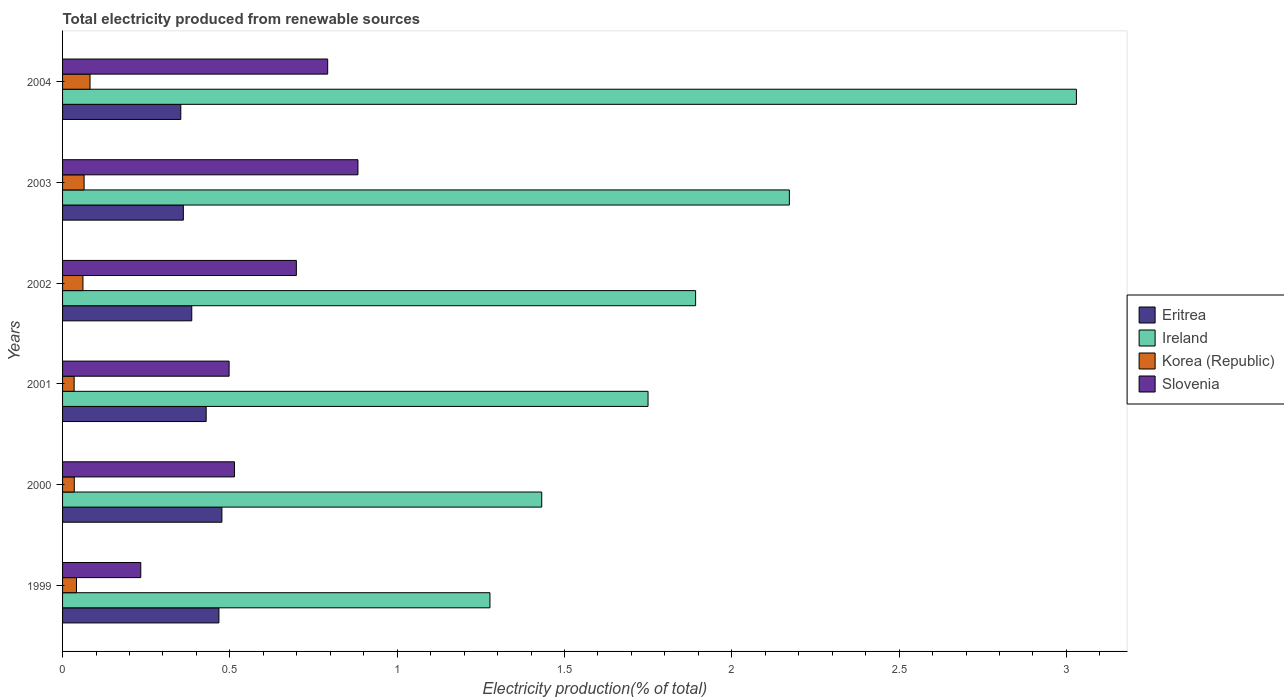How many different coloured bars are there?
Ensure brevity in your answer.  4. Are the number of bars per tick equal to the number of legend labels?
Give a very brief answer. Yes. Are the number of bars on each tick of the Y-axis equal?
Ensure brevity in your answer.  Yes. How many bars are there on the 5th tick from the top?
Your answer should be very brief. 4. How many bars are there on the 5th tick from the bottom?
Offer a very short reply. 4. What is the label of the 6th group of bars from the top?
Your answer should be very brief. 1999. What is the total electricity produced in Korea (Republic) in 2002?
Your answer should be compact. 0.06. Across all years, what is the maximum total electricity produced in Ireland?
Keep it short and to the point. 3.03. Across all years, what is the minimum total electricity produced in Ireland?
Provide a succinct answer. 1.28. In which year was the total electricity produced in Slovenia minimum?
Your answer should be compact. 1999. What is the total total electricity produced in Slovenia in the graph?
Keep it short and to the point. 3.62. What is the difference between the total electricity produced in Eritrea in 1999 and that in 2002?
Your response must be concise. 0.08. What is the difference between the total electricity produced in Korea (Republic) in 2000 and the total electricity produced in Slovenia in 2003?
Your answer should be compact. -0.85. What is the average total electricity produced in Ireland per year?
Make the answer very short. 1.93. In the year 2002, what is the difference between the total electricity produced in Ireland and total electricity produced in Eritrea?
Offer a very short reply. 1.51. What is the ratio of the total electricity produced in Korea (Republic) in 1999 to that in 2000?
Offer a terse response. 1.19. Is the total electricity produced in Ireland in 2001 less than that in 2003?
Ensure brevity in your answer.  Yes. What is the difference between the highest and the second highest total electricity produced in Korea (Republic)?
Your response must be concise. 0.02. What is the difference between the highest and the lowest total electricity produced in Slovenia?
Ensure brevity in your answer.  0.65. Is it the case that in every year, the sum of the total electricity produced in Eritrea and total electricity produced in Korea (Republic) is greater than the sum of total electricity produced in Ireland and total electricity produced in Slovenia?
Offer a very short reply. No. What does the 3rd bar from the top in 2002 represents?
Ensure brevity in your answer.  Ireland. What does the 3rd bar from the bottom in 2000 represents?
Make the answer very short. Korea (Republic). Are all the bars in the graph horizontal?
Give a very brief answer. Yes. Where does the legend appear in the graph?
Keep it short and to the point. Center right. How many legend labels are there?
Offer a terse response. 4. What is the title of the graph?
Offer a terse response. Total electricity produced from renewable sources. What is the Electricity production(% of total) in Eritrea in 1999?
Make the answer very short. 0.47. What is the Electricity production(% of total) in Ireland in 1999?
Ensure brevity in your answer.  1.28. What is the Electricity production(% of total) in Korea (Republic) in 1999?
Make the answer very short. 0.04. What is the Electricity production(% of total) in Slovenia in 1999?
Your response must be concise. 0.23. What is the Electricity production(% of total) in Eritrea in 2000?
Keep it short and to the point. 0.48. What is the Electricity production(% of total) in Ireland in 2000?
Provide a succinct answer. 1.43. What is the Electricity production(% of total) of Korea (Republic) in 2000?
Offer a terse response. 0.04. What is the Electricity production(% of total) in Slovenia in 2000?
Your answer should be compact. 0.51. What is the Electricity production(% of total) in Eritrea in 2001?
Offer a very short reply. 0.43. What is the Electricity production(% of total) of Ireland in 2001?
Provide a succinct answer. 1.75. What is the Electricity production(% of total) of Korea (Republic) in 2001?
Offer a terse response. 0.03. What is the Electricity production(% of total) of Slovenia in 2001?
Provide a succinct answer. 0.5. What is the Electricity production(% of total) of Eritrea in 2002?
Provide a succinct answer. 0.39. What is the Electricity production(% of total) in Ireland in 2002?
Your response must be concise. 1.89. What is the Electricity production(% of total) in Korea (Republic) in 2002?
Your answer should be very brief. 0.06. What is the Electricity production(% of total) in Slovenia in 2002?
Ensure brevity in your answer.  0.7. What is the Electricity production(% of total) of Eritrea in 2003?
Your answer should be very brief. 0.36. What is the Electricity production(% of total) in Ireland in 2003?
Make the answer very short. 2.17. What is the Electricity production(% of total) of Korea (Republic) in 2003?
Provide a succinct answer. 0.06. What is the Electricity production(% of total) in Slovenia in 2003?
Give a very brief answer. 0.88. What is the Electricity production(% of total) in Eritrea in 2004?
Make the answer very short. 0.35. What is the Electricity production(% of total) in Ireland in 2004?
Ensure brevity in your answer.  3.03. What is the Electricity production(% of total) of Korea (Republic) in 2004?
Your answer should be compact. 0.08. What is the Electricity production(% of total) of Slovenia in 2004?
Provide a short and direct response. 0.79. Across all years, what is the maximum Electricity production(% of total) in Eritrea?
Provide a succinct answer. 0.48. Across all years, what is the maximum Electricity production(% of total) in Ireland?
Your answer should be very brief. 3.03. Across all years, what is the maximum Electricity production(% of total) of Korea (Republic)?
Keep it short and to the point. 0.08. Across all years, what is the maximum Electricity production(% of total) in Slovenia?
Provide a short and direct response. 0.88. Across all years, what is the minimum Electricity production(% of total) of Eritrea?
Provide a succinct answer. 0.35. Across all years, what is the minimum Electricity production(% of total) in Ireland?
Ensure brevity in your answer.  1.28. Across all years, what is the minimum Electricity production(% of total) in Korea (Republic)?
Provide a short and direct response. 0.03. Across all years, what is the minimum Electricity production(% of total) in Slovenia?
Ensure brevity in your answer.  0.23. What is the total Electricity production(% of total) of Eritrea in the graph?
Your answer should be very brief. 2.47. What is the total Electricity production(% of total) of Ireland in the graph?
Your response must be concise. 11.55. What is the total Electricity production(% of total) of Korea (Republic) in the graph?
Keep it short and to the point. 0.32. What is the total Electricity production(% of total) of Slovenia in the graph?
Your answer should be compact. 3.62. What is the difference between the Electricity production(% of total) of Eritrea in 1999 and that in 2000?
Your answer should be very brief. -0.01. What is the difference between the Electricity production(% of total) of Ireland in 1999 and that in 2000?
Your answer should be compact. -0.15. What is the difference between the Electricity production(% of total) in Korea (Republic) in 1999 and that in 2000?
Offer a terse response. 0.01. What is the difference between the Electricity production(% of total) in Slovenia in 1999 and that in 2000?
Ensure brevity in your answer.  -0.28. What is the difference between the Electricity production(% of total) of Eritrea in 1999 and that in 2001?
Keep it short and to the point. 0.04. What is the difference between the Electricity production(% of total) in Ireland in 1999 and that in 2001?
Your answer should be compact. -0.47. What is the difference between the Electricity production(% of total) of Korea (Republic) in 1999 and that in 2001?
Give a very brief answer. 0.01. What is the difference between the Electricity production(% of total) of Slovenia in 1999 and that in 2001?
Your answer should be compact. -0.26. What is the difference between the Electricity production(% of total) of Eritrea in 1999 and that in 2002?
Ensure brevity in your answer.  0.08. What is the difference between the Electricity production(% of total) in Ireland in 1999 and that in 2002?
Make the answer very short. -0.61. What is the difference between the Electricity production(% of total) in Korea (Republic) in 1999 and that in 2002?
Offer a very short reply. -0.02. What is the difference between the Electricity production(% of total) of Slovenia in 1999 and that in 2002?
Ensure brevity in your answer.  -0.47. What is the difference between the Electricity production(% of total) in Eritrea in 1999 and that in 2003?
Ensure brevity in your answer.  0.11. What is the difference between the Electricity production(% of total) in Ireland in 1999 and that in 2003?
Provide a succinct answer. -0.89. What is the difference between the Electricity production(% of total) of Korea (Republic) in 1999 and that in 2003?
Make the answer very short. -0.02. What is the difference between the Electricity production(% of total) in Slovenia in 1999 and that in 2003?
Provide a short and direct response. -0.65. What is the difference between the Electricity production(% of total) of Eritrea in 1999 and that in 2004?
Keep it short and to the point. 0.11. What is the difference between the Electricity production(% of total) of Ireland in 1999 and that in 2004?
Your response must be concise. -1.75. What is the difference between the Electricity production(% of total) of Korea (Republic) in 1999 and that in 2004?
Your answer should be very brief. -0.04. What is the difference between the Electricity production(% of total) in Slovenia in 1999 and that in 2004?
Give a very brief answer. -0.56. What is the difference between the Electricity production(% of total) of Eritrea in 2000 and that in 2001?
Make the answer very short. 0.05. What is the difference between the Electricity production(% of total) of Ireland in 2000 and that in 2001?
Your response must be concise. -0.32. What is the difference between the Electricity production(% of total) in Korea (Republic) in 2000 and that in 2001?
Keep it short and to the point. 0. What is the difference between the Electricity production(% of total) of Slovenia in 2000 and that in 2001?
Offer a terse response. 0.02. What is the difference between the Electricity production(% of total) of Eritrea in 2000 and that in 2002?
Your answer should be very brief. 0.09. What is the difference between the Electricity production(% of total) of Ireland in 2000 and that in 2002?
Your response must be concise. -0.46. What is the difference between the Electricity production(% of total) in Korea (Republic) in 2000 and that in 2002?
Give a very brief answer. -0.03. What is the difference between the Electricity production(% of total) of Slovenia in 2000 and that in 2002?
Provide a short and direct response. -0.18. What is the difference between the Electricity production(% of total) in Eritrea in 2000 and that in 2003?
Your answer should be compact. 0.12. What is the difference between the Electricity production(% of total) of Ireland in 2000 and that in 2003?
Offer a very short reply. -0.74. What is the difference between the Electricity production(% of total) of Korea (Republic) in 2000 and that in 2003?
Provide a succinct answer. -0.03. What is the difference between the Electricity production(% of total) of Slovenia in 2000 and that in 2003?
Provide a succinct answer. -0.37. What is the difference between the Electricity production(% of total) in Eritrea in 2000 and that in 2004?
Provide a succinct answer. 0.12. What is the difference between the Electricity production(% of total) in Ireland in 2000 and that in 2004?
Your answer should be compact. -1.6. What is the difference between the Electricity production(% of total) of Korea (Republic) in 2000 and that in 2004?
Provide a short and direct response. -0.05. What is the difference between the Electricity production(% of total) in Slovenia in 2000 and that in 2004?
Provide a short and direct response. -0.28. What is the difference between the Electricity production(% of total) in Eritrea in 2001 and that in 2002?
Ensure brevity in your answer.  0.04. What is the difference between the Electricity production(% of total) in Ireland in 2001 and that in 2002?
Your answer should be compact. -0.14. What is the difference between the Electricity production(% of total) of Korea (Republic) in 2001 and that in 2002?
Offer a very short reply. -0.03. What is the difference between the Electricity production(% of total) of Slovenia in 2001 and that in 2002?
Your answer should be compact. -0.2. What is the difference between the Electricity production(% of total) in Eritrea in 2001 and that in 2003?
Your answer should be compact. 0.07. What is the difference between the Electricity production(% of total) of Ireland in 2001 and that in 2003?
Keep it short and to the point. -0.42. What is the difference between the Electricity production(% of total) in Korea (Republic) in 2001 and that in 2003?
Provide a succinct answer. -0.03. What is the difference between the Electricity production(% of total) of Slovenia in 2001 and that in 2003?
Keep it short and to the point. -0.39. What is the difference between the Electricity production(% of total) of Eritrea in 2001 and that in 2004?
Your response must be concise. 0.08. What is the difference between the Electricity production(% of total) in Ireland in 2001 and that in 2004?
Ensure brevity in your answer.  -1.28. What is the difference between the Electricity production(% of total) in Korea (Republic) in 2001 and that in 2004?
Offer a terse response. -0.05. What is the difference between the Electricity production(% of total) in Slovenia in 2001 and that in 2004?
Your answer should be very brief. -0.29. What is the difference between the Electricity production(% of total) of Eritrea in 2002 and that in 2003?
Provide a succinct answer. 0.03. What is the difference between the Electricity production(% of total) of Ireland in 2002 and that in 2003?
Make the answer very short. -0.28. What is the difference between the Electricity production(% of total) in Korea (Republic) in 2002 and that in 2003?
Ensure brevity in your answer.  -0. What is the difference between the Electricity production(% of total) in Slovenia in 2002 and that in 2003?
Your answer should be very brief. -0.18. What is the difference between the Electricity production(% of total) in Eritrea in 2002 and that in 2004?
Offer a terse response. 0.03. What is the difference between the Electricity production(% of total) in Ireland in 2002 and that in 2004?
Make the answer very short. -1.14. What is the difference between the Electricity production(% of total) of Korea (Republic) in 2002 and that in 2004?
Your answer should be compact. -0.02. What is the difference between the Electricity production(% of total) in Slovenia in 2002 and that in 2004?
Provide a succinct answer. -0.09. What is the difference between the Electricity production(% of total) in Eritrea in 2003 and that in 2004?
Give a very brief answer. 0.01. What is the difference between the Electricity production(% of total) in Ireland in 2003 and that in 2004?
Make the answer very short. -0.86. What is the difference between the Electricity production(% of total) of Korea (Republic) in 2003 and that in 2004?
Your answer should be compact. -0.02. What is the difference between the Electricity production(% of total) of Slovenia in 2003 and that in 2004?
Offer a terse response. 0.09. What is the difference between the Electricity production(% of total) in Eritrea in 1999 and the Electricity production(% of total) in Ireland in 2000?
Your answer should be very brief. -0.96. What is the difference between the Electricity production(% of total) of Eritrea in 1999 and the Electricity production(% of total) of Korea (Republic) in 2000?
Your answer should be very brief. 0.43. What is the difference between the Electricity production(% of total) of Eritrea in 1999 and the Electricity production(% of total) of Slovenia in 2000?
Ensure brevity in your answer.  -0.05. What is the difference between the Electricity production(% of total) of Ireland in 1999 and the Electricity production(% of total) of Korea (Republic) in 2000?
Offer a terse response. 1.24. What is the difference between the Electricity production(% of total) of Ireland in 1999 and the Electricity production(% of total) of Slovenia in 2000?
Ensure brevity in your answer.  0.76. What is the difference between the Electricity production(% of total) of Korea (Republic) in 1999 and the Electricity production(% of total) of Slovenia in 2000?
Offer a terse response. -0.47. What is the difference between the Electricity production(% of total) of Eritrea in 1999 and the Electricity production(% of total) of Ireland in 2001?
Offer a very short reply. -1.28. What is the difference between the Electricity production(% of total) of Eritrea in 1999 and the Electricity production(% of total) of Korea (Republic) in 2001?
Ensure brevity in your answer.  0.43. What is the difference between the Electricity production(% of total) of Eritrea in 1999 and the Electricity production(% of total) of Slovenia in 2001?
Provide a short and direct response. -0.03. What is the difference between the Electricity production(% of total) of Ireland in 1999 and the Electricity production(% of total) of Korea (Republic) in 2001?
Give a very brief answer. 1.24. What is the difference between the Electricity production(% of total) in Ireland in 1999 and the Electricity production(% of total) in Slovenia in 2001?
Offer a very short reply. 0.78. What is the difference between the Electricity production(% of total) in Korea (Republic) in 1999 and the Electricity production(% of total) in Slovenia in 2001?
Your answer should be very brief. -0.46. What is the difference between the Electricity production(% of total) in Eritrea in 1999 and the Electricity production(% of total) in Ireland in 2002?
Make the answer very short. -1.42. What is the difference between the Electricity production(% of total) of Eritrea in 1999 and the Electricity production(% of total) of Korea (Republic) in 2002?
Provide a short and direct response. 0.41. What is the difference between the Electricity production(% of total) in Eritrea in 1999 and the Electricity production(% of total) in Slovenia in 2002?
Your response must be concise. -0.23. What is the difference between the Electricity production(% of total) in Ireland in 1999 and the Electricity production(% of total) in Korea (Republic) in 2002?
Offer a very short reply. 1.22. What is the difference between the Electricity production(% of total) in Ireland in 1999 and the Electricity production(% of total) in Slovenia in 2002?
Provide a succinct answer. 0.58. What is the difference between the Electricity production(% of total) of Korea (Republic) in 1999 and the Electricity production(% of total) of Slovenia in 2002?
Your response must be concise. -0.66. What is the difference between the Electricity production(% of total) in Eritrea in 1999 and the Electricity production(% of total) in Ireland in 2003?
Give a very brief answer. -1.7. What is the difference between the Electricity production(% of total) in Eritrea in 1999 and the Electricity production(% of total) in Korea (Republic) in 2003?
Offer a terse response. 0.4. What is the difference between the Electricity production(% of total) in Eritrea in 1999 and the Electricity production(% of total) in Slovenia in 2003?
Make the answer very short. -0.42. What is the difference between the Electricity production(% of total) of Ireland in 1999 and the Electricity production(% of total) of Korea (Republic) in 2003?
Your answer should be very brief. 1.21. What is the difference between the Electricity production(% of total) of Ireland in 1999 and the Electricity production(% of total) of Slovenia in 2003?
Make the answer very short. 0.39. What is the difference between the Electricity production(% of total) in Korea (Republic) in 1999 and the Electricity production(% of total) in Slovenia in 2003?
Offer a terse response. -0.84. What is the difference between the Electricity production(% of total) in Eritrea in 1999 and the Electricity production(% of total) in Ireland in 2004?
Your answer should be compact. -2.56. What is the difference between the Electricity production(% of total) of Eritrea in 1999 and the Electricity production(% of total) of Korea (Republic) in 2004?
Your answer should be very brief. 0.39. What is the difference between the Electricity production(% of total) in Eritrea in 1999 and the Electricity production(% of total) in Slovenia in 2004?
Your response must be concise. -0.33. What is the difference between the Electricity production(% of total) in Ireland in 1999 and the Electricity production(% of total) in Korea (Republic) in 2004?
Your answer should be compact. 1.2. What is the difference between the Electricity production(% of total) of Ireland in 1999 and the Electricity production(% of total) of Slovenia in 2004?
Offer a very short reply. 0.48. What is the difference between the Electricity production(% of total) of Korea (Republic) in 1999 and the Electricity production(% of total) of Slovenia in 2004?
Ensure brevity in your answer.  -0.75. What is the difference between the Electricity production(% of total) in Eritrea in 2000 and the Electricity production(% of total) in Ireland in 2001?
Your response must be concise. -1.27. What is the difference between the Electricity production(% of total) in Eritrea in 2000 and the Electricity production(% of total) in Korea (Republic) in 2001?
Ensure brevity in your answer.  0.44. What is the difference between the Electricity production(% of total) in Eritrea in 2000 and the Electricity production(% of total) in Slovenia in 2001?
Keep it short and to the point. -0.02. What is the difference between the Electricity production(% of total) of Ireland in 2000 and the Electricity production(% of total) of Korea (Republic) in 2001?
Make the answer very short. 1.4. What is the difference between the Electricity production(% of total) in Ireland in 2000 and the Electricity production(% of total) in Slovenia in 2001?
Give a very brief answer. 0.93. What is the difference between the Electricity production(% of total) in Korea (Republic) in 2000 and the Electricity production(% of total) in Slovenia in 2001?
Offer a terse response. -0.46. What is the difference between the Electricity production(% of total) of Eritrea in 2000 and the Electricity production(% of total) of Ireland in 2002?
Offer a very short reply. -1.42. What is the difference between the Electricity production(% of total) in Eritrea in 2000 and the Electricity production(% of total) in Korea (Republic) in 2002?
Give a very brief answer. 0.42. What is the difference between the Electricity production(% of total) of Eritrea in 2000 and the Electricity production(% of total) of Slovenia in 2002?
Give a very brief answer. -0.22. What is the difference between the Electricity production(% of total) of Ireland in 2000 and the Electricity production(% of total) of Korea (Republic) in 2002?
Your response must be concise. 1.37. What is the difference between the Electricity production(% of total) in Ireland in 2000 and the Electricity production(% of total) in Slovenia in 2002?
Keep it short and to the point. 0.73. What is the difference between the Electricity production(% of total) of Korea (Republic) in 2000 and the Electricity production(% of total) of Slovenia in 2002?
Give a very brief answer. -0.66. What is the difference between the Electricity production(% of total) in Eritrea in 2000 and the Electricity production(% of total) in Ireland in 2003?
Make the answer very short. -1.7. What is the difference between the Electricity production(% of total) in Eritrea in 2000 and the Electricity production(% of total) in Korea (Republic) in 2003?
Keep it short and to the point. 0.41. What is the difference between the Electricity production(% of total) of Eritrea in 2000 and the Electricity production(% of total) of Slovenia in 2003?
Your answer should be very brief. -0.41. What is the difference between the Electricity production(% of total) in Ireland in 2000 and the Electricity production(% of total) in Korea (Republic) in 2003?
Your answer should be very brief. 1.37. What is the difference between the Electricity production(% of total) of Ireland in 2000 and the Electricity production(% of total) of Slovenia in 2003?
Offer a very short reply. 0.55. What is the difference between the Electricity production(% of total) of Korea (Republic) in 2000 and the Electricity production(% of total) of Slovenia in 2003?
Your answer should be very brief. -0.85. What is the difference between the Electricity production(% of total) of Eritrea in 2000 and the Electricity production(% of total) of Ireland in 2004?
Your response must be concise. -2.55. What is the difference between the Electricity production(% of total) in Eritrea in 2000 and the Electricity production(% of total) in Korea (Republic) in 2004?
Your answer should be compact. 0.39. What is the difference between the Electricity production(% of total) in Eritrea in 2000 and the Electricity production(% of total) in Slovenia in 2004?
Make the answer very short. -0.32. What is the difference between the Electricity production(% of total) in Ireland in 2000 and the Electricity production(% of total) in Korea (Republic) in 2004?
Provide a short and direct response. 1.35. What is the difference between the Electricity production(% of total) in Ireland in 2000 and the Electricity production(% of total) in Slovenia in 2004?
Keep it short and to the point. 0.64. What is the difference between the Electricity production(% of total) in Korea (Republic) in 2000 and the Electricity production(% of total) in Slovenia in 2004?
Make the answer very short. -0.76. What is the difference between the Electricity production(% of total) in Eritrea in 2001 and the Electricity production(% of total) in Ireland in 2002?
Your response must be concise. -1.46. What is the difference between the Electricity production(% of total) in Eritrea in 2001 and the Electricity production(% of total) in Korea (Republic) in 2002?
Offer a very short reply. 0.37. What is the difference between the Electricity production(% of total) in Eritrea in 2001 and the Electricity production(% of total) in Slovenia in 2002?
Offer a very short reply. -0.27. What is the difference between the Electricity production(% of total) of Ireland in 2001 and the Electricity production(% of total) of Korea (Republic) in 2002?
Your response must be concise. 1.69. What is the difference between the Electricity production(% of total) in Ireland in 2001 and the Electricity production(% of total) in Slovenia in 2002?
Your answer should be compact. 1.05. What is the difference between the Electricity production(% of total) of Korea (Republic) in 2001 and the Electricity production(% of total) of Slovenia in 2002?
Offer a terse response. -0.66. What is the difference between the Electricity production(% of total) of Eritrea in 2001 and the Electricity production(% of total) of Ireland in 2003?
Provide a succinct answer. -1.74. What is the difference between the Electricity production(% of total) in Eritrea in 2001 and the Electricity production(% of total) in Korea (Republic) in 2003?
Your answer should be very brief. 0.36. What is the difference between the Electricity production(% of total) in Eritrea in 2001 and the Electricity production(% of total) in Slovenia in 2003?
Give a very brief answer. -0.45. What is the difference between the Electricity production(% of total) of Ireland in 2001 and the Electricity production(% of total) of Korea (Republic) in 2003?
Give a very brief answer. 1.69. What is the difference between the Electricity production(% of total) in Ireland in 2001 and the Electricity production(% of total) in Slovenia in 2003?
Your answer should be compact. 0.87. What is the difference between the Electricity production(% of total) of Korea (Republic) in 2001 and the Electricity production(% of total) of Slovenia in 2003?
Provide a succinct answer. -0.85. What is the difference between the Electricity production(% of total) of Eritrea in 2001 and the Electricity production(% of total) of Ireland in 2004?
Ensure brevity in your answer.  -2.6. What is the difference between the Electricity production(% of total) of Eritrea in 2001 and the Electricity production(% of total) of Korea (Republic) in 2004?
Provide a short and direct response. 0.35. What is the difference between the Electricity production(% of total) in Eritrea in 2001 and the Electricity production(% of total) in Slovenia in 2004?
Provide a short and direct response. -0.36. What is the difference between the Electricity production(% of total) of Ireland in 2001 and the Electricity production(% of total) of Korea (Republic) in 2004?
Offer a very short reply. 1.67. What is the difference between the Electricity production(% of total) of Ireland in 2001 and the Electricity production(% of total) of Slovenia in 2004?
Make the answer very short. 0.96. What is the difference between the Electricity production(% of total) of Korea (Republic) in 2001 and the Electricity production(% of total) of Slovenia in 2004?
Keep it short and to the point. -0.76. What is the difference between the Electricity production(% of total) in Eritrea in 2002 and the Electricity production(% of total) in Ireland in 2003?
Offer a very short reply. -1.79. What is the difference between the Electricity production(% of total) in Eritrea in 2002 and the Electricity production(% of total) in Korea (Republic) in 2003?
Your response must be concise. 0.32. What is the difference between the Electricity production(% of total) in Eritrea in 2002 and the Electricity production(% of total) in Slovenia in 2003?
Make the answer very short. -0.5. What is the difference between the Electricity production(% of total) in Ireland in 2002 and the Electricity production(% of total) in Korea (Republic) in 2003?
Your answer should be compact. 1.83. What is the difference between the Electricity production(% of total) of Ireland in 2002 and the Electricity production(% of total) of Slovenia in 2003?
Your answer should be compact. 1.01. What is the difference between the Electricity production(% of total) of Korea (Republic) in 2002 and the Electricity production(% of total) of Slovenia in 2003?
Make the answer very short. -0.82. What is the difference between the Electricity production(% of total) in Eritrea in 2002 and the Electricity production(% of total) in Ireland in 2004?
Provide a short and direct response. -2.64. What is the difference between the Electricity production(% of total) of Eritrea in 2002 and the Electricity production(% of total) of Korea (Republic) in 2004?
Provide a succinct answer. 0.3. What is the difference between the Electricity production(% of total) in Eritrea in 2002 and the Electricity production(% of total) in Slovenia in 2004?
Offer a terse response. -0.41. What is the difference between the Electricity production(% of total) in Ireland in 2002 and the Electricity production(% of total) in Korea (Republic) in 2004?
Ensure brevity in your answer.  1.81. What is the difference between the Electricity production(% of total) of Ireland in 2002 and the Electricity production(% of total) of Slovenia in 2004?
Your answer should be compact. 1.1. What is the difference between the Electricity production(% of total) in Korea (Republic) in 2002 and the Electricity production(% of total) in Slovenia in 2004?
Make the answer very short. -0.73. What is the difference between the Electricity production(% of total) of Eritrea in 2003 and the Electricity production(% of total) of Ireland in 2004?
Offer a terse response. -2.67. What is the difference between the Electricity production(% of total) in Eritrea in 2003 and the Electricity production(% of total) in Korea (Republic) in 2004?
Your answer should be compact. 0.28. What is the difference between the Electricity production(% of total) in Eritrea in 2003 and the Electricity production(% of total) in Slovenia in 2004?
Offer a very short reply. -0.43. What is the difference between the Electricity production(% of total) of Ireland in 2003 and the Electricity production(% of total) of Korea (Republic) in 2004?
Keep it short and to the point. 2.09. What is the difference between the Electricity production(% of total) of Ireland in 2003 and the Electricity production(% of total) of Slovenia in 2004?
Your answer should be compact. 1.38. What is the difference between the Electricity production(% of total) of Korea (Republic) in 2003 and the Electricity production(% of total) of Slovenia in 2004?
Make the answer very short. -0.73. What is the average Electricity production(% of total) of Eritrea per year?
Your answer should be compact. 0.41. What is the average Electricity production(% of total) of Ireland per year?
Your answer should be compact. 1.93. What is the average Electricity production(% of total) of Korea (Republic) per year?
Your answer should be compact. 0.05. What is the average Electricity production(% of total) in Slovenia per year?
Give a very brief answer. 0.6. In the year 1999, what is the difference between the Electricity production(% of total) in Eritrea and Electricity production(% of total) in Ireland?
Your answer should be very brief. -0.81. In the year 1999, what is the difference between the Electricity production(% of total) of Eritrea and Electricity production(% of total) of Korea (Republic)?
Your answer should be compact. 0.43. In the year 1999, what is the difference between the Electricity production(% of total) in Eritrea and Electricity production(% of total) in Slovenia?
Make the answer very short. 0.23. In the year 1999, what is the difference between the Electricity production(% of total) in Ireland and Electricity production(% of total) in Korea (Republic)?
Your answer should be very brief. 1.24. In the year 1999, what is the difference between the Electricity production(% of total) in Ireland and Electricity production(% of total) in Slovenia?
Make the answer very short. 1.04. In the year 1999, what is the difference between the Electricity production(% of total) in Korea (Republic) and Electricity production(% of total) in Slovenia?
Make the answer very short. -0.19. In the year 2000, what is the difference between the Electricity production(% of total) in Eritrea and Electricity production(% of total) in Ireland?
Make the answer very short. -0.96. In the year 2000, what is the difference between the Electricity production(% of total) of Eritrea and Electricity production(% of total) of Korea (Republic)?
Give a very brief answer. 0.44. In the year 2000, what is the difference between the Electricity production(% of total) in Eritrea and Electricity production(% of total) in Slovenia?
Provide a succinct answer. -0.04. In the year 2000, what is the difference between the Electricity production(% of total) in Ireland and Electricity production(% of total) in Korea (Republic)?
Give a very brief answer. 1.4. In the year 2000, what is the difference between the Electricity production(% of total) of Ireland and Electricity production(% of total) of Slovenia?
Ensure brevity in your answer.  0.92. In the year 2000, what is the difference between the Electricity production(% of total) in Korea (Republic) and Electricity production(% of total) in Slovenia?
Offer a very short reply. -0.48. In the year 2001, what is the difference between the Electricity production(% of total) of Eritrea and Electricity production(% of total) of Ireland?
Provide a short and direct response. -1.32. In the year 2001, what is the difference between the Electricity production(% of total) of Eritrea and Electricity production(% of total) of Korea (Republic)?
Your answer should be compact. 0.39. In the year 2001, what is the difference between the Electricity production(% of total) of Eritrea and Electricity production(% of total) of Slovenia?
Keep it short and to the point. -0.07. In the year 2001, what is the difference between the Electricity production(% of total) in Ireland and Electricity production(% of total) in Korea (Republic)?
Offer a terse response. 1.72. In the year 2001, what is the difference between the Electricity production(% of total) in Ireland and Electricity production(% of total) in Slovenia?
Provide a succinct answer. 1.25. In the year 2001, what is the difference between the Electricity production(% of total) in Korea (Republic) and Electricity production(% of total) in Slovenia?
Your answer should be compact. -0.46. In the year 2002, what is the difference between the Electricity production(% of total) of Eritrea and Electricity production(% of total) of Ireland?
Provide a succinct answer. -1.51. In the year 2002, what is the difference between the Electricity production(% of total) of Eritrea and Electricity production(% of total) of Korea (Republic)?
Keep it short and to the point. 0.33. In the year 2002, what is the difference between the Electricity production(% of total) of Eritrea and Electricity production(% of total) of Slovenia?
Keep it short and to the point. -0.31. In the year 2002, what is the difference between the Electricity production(% of total) of Ireland and Electricity production(% of total) of Korea (Republic)?
Provide a short and direct response. 1.83. In the year 2002, what is the difference between the Electricity production(% of total) of Ireland and Electricity production(% of total) of Slovenia?
Your answer should be compact. 1.19. In the year 2002, what is the difference between the Electricity production(% of total) of Korea (Republic) and Electricity production(% of total) of Slovenia?
Give a very brief answer. -0.64. In the year 2003, what is the difference between the Electricity production(% of total) of Eritrea and Electricity production(% of total) of Ireland?
Provide a succinct answer. -1.81. In the year 2003, what is the difference between the Electricity production(% of total) in Eritrea and Electricity production(% of total) in Korea (Republic)?
Make the answer very short. 0.3. In the year 2003, what is the difference between the Electricity production(% of total) of Eritrea and Electricity production(% of total) of Slovenia?
Make the answer very short. -0.52. In the year 2003, what is the difference between the Electricity production(% of total) of Ireland and Electricity production(% of total) of Korea (Republic)?
Offer a terse response. 2.11. In the year 2003, what is the difference between the Electricity production(% of total) of Ireland and Electricity production(% of total) of Slovenia?
Your answer should be compact. 1.29. In the year 2003, what is the difference between the Electricity production(% of total) in Korea (Republic) and Electricity production(% of total) in Slovenia?
Provide a short and direct response. -0.82. In the year 2004, what is the difference between the Electricity production(% of total) in Eritrea and Electricity production(% of total) in Ireland?
Keep it short and to the point. -2.68. In the year 2004, what is the difference between the Electricity production(% of total) in Eritrea and Electricity production(% of total) in Korea (Republic)?
Keep it short and to the point. 0.27. In the year 2004, what is the difference between the Electricity production(% of total) in Eritrea and Electricity production(% of total) in Slovenia?
Offer a terse response. -0.44. In the year 2004, what is the difference between the Electricity production(% of total) in Ireland and Electricity production(% of total) in Korea (Republic)?
Ensure brevity in your answer.  2.95. In the year 2004, what is the difference between the Electricity production(% of total) in Ireland and Electricity production(% of total) in Slovenia?
Make the answer very short. 2.24. In the year 2004, what is the difference between the Electricity production(% of total) in Korea (Republic) and Electricity production(% of total) in Slovenia?
Provide a succinct answer. -0.71. What is the ratio of the Electricity production(% of total) of Eritrea in 1999 to that in 2000?
Provide a short and direct response. 0.98. What is the ratio of the Electricity production(% of total) of Ireland in 1999 to that in 2000?
Ensure brevity in your answer.  0.89. What is the ratio of the Electricity production(% of total) in Korea (Republic) in 1999 to that in 2000?
Give a very brief answer. 1.19. What is the ratio of the Electricity production(% of total) of Slovenia in 1999 to that in 2000?
Make the answer very short. 0.45. What is the ratio of the Electricity production(% of total) of Eritrea in 1999 to that in 2001?
Your answer should be compact. 1.09. What is the ratio of the Electricity production(% of total) in Ireland in 1999 to that in 2001?
Offer a very short reply. 0.73. What is the ratio of the Electricity production(% of total) of Korea (Republic) in 1999 to that in 2001?
Your answer should be compact. 1.2. What is the ratio of the Electricity production(% of total) of Slovenia in 1999 to that in 2001?
Provide a short and direct response. 0.47. What is the ratio of the Electricity production(% of total) of Eritrea in 1999 to that in 2002?
Provide a short and direct response. 1.21. What is the ratio of the Electricity production(% of total) in Ireland in 1999 to that in 2002?
Offer a very short reply. 0.68. What is the ratio of the Electricity production(% of total) in Korea (Republic) in 1999 to that in 2002?
Make the answer very short. 0.68. What is the ratio of the Electricity production(% of total) in Slovenia in 1999 to that in 2002?
Give a very brief answer. 0.33. What is the ratio of the Electricity production(% of total) of Eritrea in 1999 to that in 2003?
Give a very brief answer. 1.29. What is the ratio of the Electricity production(% of total) of Ireland in 1999 to that in 2003?
Your answer should be very brief. 0.59. What is the ratio of the Electricity production(% of total) of Korea (Republic) in 1999 to that in 2003?
Provide a succinct answer. 0.65. What is the ratio of the Electricity production(% of total) in Slovenia in 1999 to that in 2003?
Your response must be concise. 0.26. What is the ratio of the Electricity production(% of total) of Eritrea in 1999 to that in 2004?
Offer a very short reply. 1.32. What is the ratio of the Electricity production(% of total) in Ireland in 1999 to that in 2004?
Your response must be concise. 0.42. What is the ratio of the Electricity production(% of total) in Korea (Republic) in 1999 to that in 2004?
Provide a succinct answer. 0.51. What is the ratio of the Electricity production(% of total) in Slovenia in 1999 to that in 2004?
Make the answer very short. 0.29. What is the ratio of the Electricity production(% of total) in Eritrea in 2000 to that in 2001?
Provide a succinct answer. 1.11. What is the ratio of the Electricity production(% of total) of Ireland in 2000 to that in 2001?
Your answer should be very brief. 0.82. What is the ratio of the Electricity production(% of total) of Korea (Republic) in 2000 to that in 2001?
Give a very brief answer. 1.01. What is the ratio of the Electricity production(% of total) in Slovenia in 2000 to that in 2001?
Offer a terse response. 1.03. What is the ratio of the Electricity production(% of total) in Eritrea in 2000 to that in 2002?
Provide a succinct answer. 1.23. What is the ratio of the Electricity production(% of total) of Ireland in 2000 to that in 2002?
Provide a short and direct response. 0.76. What is the ratio of the Electricity production(% of total) in Korea (Republic) in 2000 to that in 2002?
Your response must be concise. 0.57. What is the ratio of the Electricity production(% of total) in Slovenia in 2000 to that in 2002?
Your answer should be very brief. 0.74. What is the ratio of the Electricity production(% of total) in Eritrea in 2000 to that in 2003?
Keep it short and to the point. 1.32. What is the ratio of the Electricity production(% of total) of Ireland in 2000 to that in 2003?
Your answer should be compact. 0.66. What is the ratio of the Electricity production(% of total) of Korea (Republic) in 2000 to that in 2003?
Your answer should be very brief. 0.54. What is the ratio of the Electricity production(% of total) of Slovenia in 2000 to that in 2003?
Keep it short and to the point. 0.58. What is the ratio of the Electricity production(% of total) of Eritrea in 2000 to that in 2004?
Make the answer very short. 1.35. What is the ratio of the Electricity production(% of total) of Ireland in 2000 to that in 2004?
Your response must be concise. 0.47. What is the ratio of the Electricity production(% of total) of Korea (Republic) in 2000 to that in 2004?
Your response must be concise. 0.43. What is the ratio of the Electricity production(% of total) in Slovenia in 2000 to that in 2004?
Your answer should be very brief. 0.65. What is the ratio of the Electricity production(% of total) in Eritrea in 2001 to that in 2002?
Ensure brevity in your answer.  1.11. What is the ratio of the Electricity production(% of total) in Ireland in 2001 to that in 2002?
Your answer should be very brief. 0.92. What is the ratio of the Electricity production(% of total) in Korea (Republic) in 2001 to that in 2002?
Give a very brief answer. 0.57. What is the ratio of the Electricity production(% of total) in Slovenia in 2001 to that in 2002?
Your answer should be very brief. 0.71. What is the ratio of the Electricity production(% of total) in Eritrea in 2001 to that in 2003?
Offer a very short reply. 1.19. What is the ratio of the Electricity production(% of total) in Ireland in 2001 to that in 2003?
Your response must be concise. 0.81. What is the ratio of the Electricity production(% of total) in Korea (Republic) in 2001 to that in 2003?
Your answer should be very brief. 0.54. What is the ratio of the Electricity production(% of total) of Slovenia in 2001 to that in 2003?
Offer a terse response. 0.56. What is the ratio of the Electricity production(% of total) in Eritrea in 2001 to that in 2004?
Your response must be concise. 1.21. What is the ratio of the Electricity production(% of total) of Ireland in 2001 to that in 2004?
Keep it short and to the point. 0.58. What is the ratio of the Electricity production(% of total) in Korea (Republic) in 2001 to that in 2004?
Ensure brevity in your answer.  0.42. What is the ratio of the Electricity production(% of total) of Slovenia in 2001 to that in 2004?
Give a very brief answer. 0.63. What is the ratio of the Electricity production(% of total) of Eritrea in 2002 to that in 2003?
Your answer should be compact. 1.07. What is the ratio of the Electricity production(% of total) in Ireland in 2002 to that in 2003?
Ensure brevity in your answer.  0.87. What is the ratio of the Electricity production(% of total) in Korea (Republic) in 2002 to that in 2003?
Offer a terse response. 0.95. What is the ratio of the Electricity production(% of total) in Slovenia in 2002 to that in 2003?
Offer a terse response. 0.79. What is the ratio of the Electricity production(% of total) of Eritrea in 2002 to that in 2004?
Offer a terse response. 1.09. What is the ratio of the Electricity production(% of total) of Ireland in 2002 to that in 2004?
Keep it short and to the point. 0.62. What is the ratio of the Electricity production(% of total) in Korea (Republic) in 2002 to that in 2004?
Offer a very short reply. 0.74. What is the ratio of the Electricity production(% of total) in Slovenia in 2002 to that in 2004?
Ensure brevity in your answer.  0.88. What is the ratio of the Electricity production(% of total) in Eritrea in 2003 to that in 2004?
Provide a succinct answer. 1.02. What is the ratio of the Electricity production(% of total) of Ireland in 2003 to that in 2004?
Keep it short and to the point. 0.72. What is the ratio of the Electricity production(% of total) in Korea (Republic) in 2003 to that in 2004?
Offer a very short reply. 0.78. What is the ratio of the Electricity production(% of total) of Slovenia in 2003 to that in 2004?
Provide a short and direct response. 1.11. What is the difference between the highest and the second highest Electricity production(% of total) of Eritrea?
Keep it short and to the point. 0.01. What is the difference between the highest and the second highest Electricity production(% of total) of Ireland?
Your response must be concise. 0.86. What is the difference between the highest and the second highest Electricity production(% of total) in Korea (Republic)?
Ensure brevity in your answer.  0.02. What is the difference between the highest and the second highest Electricity production(% of total) in Slovenia?
Keep it short and to the point. 0.09. What is the difference between the highest and the lowest Electricity production(% of total) of Eritrea?
Give a very brief answer. 0.12. What is the difference between the highest and the lowest Electricity production(% of total) of Ireland?
Give a very brief answer. 1.75. What is the difference between the highest and the lowest Electricity production(% of total) in Korea (Republic)?
Provide a short and direct response. 0.05. What is the difference between the highest and the lowest Electricity production(% of total) in Slovenia?
Your answer should be very brief. 0.65. 